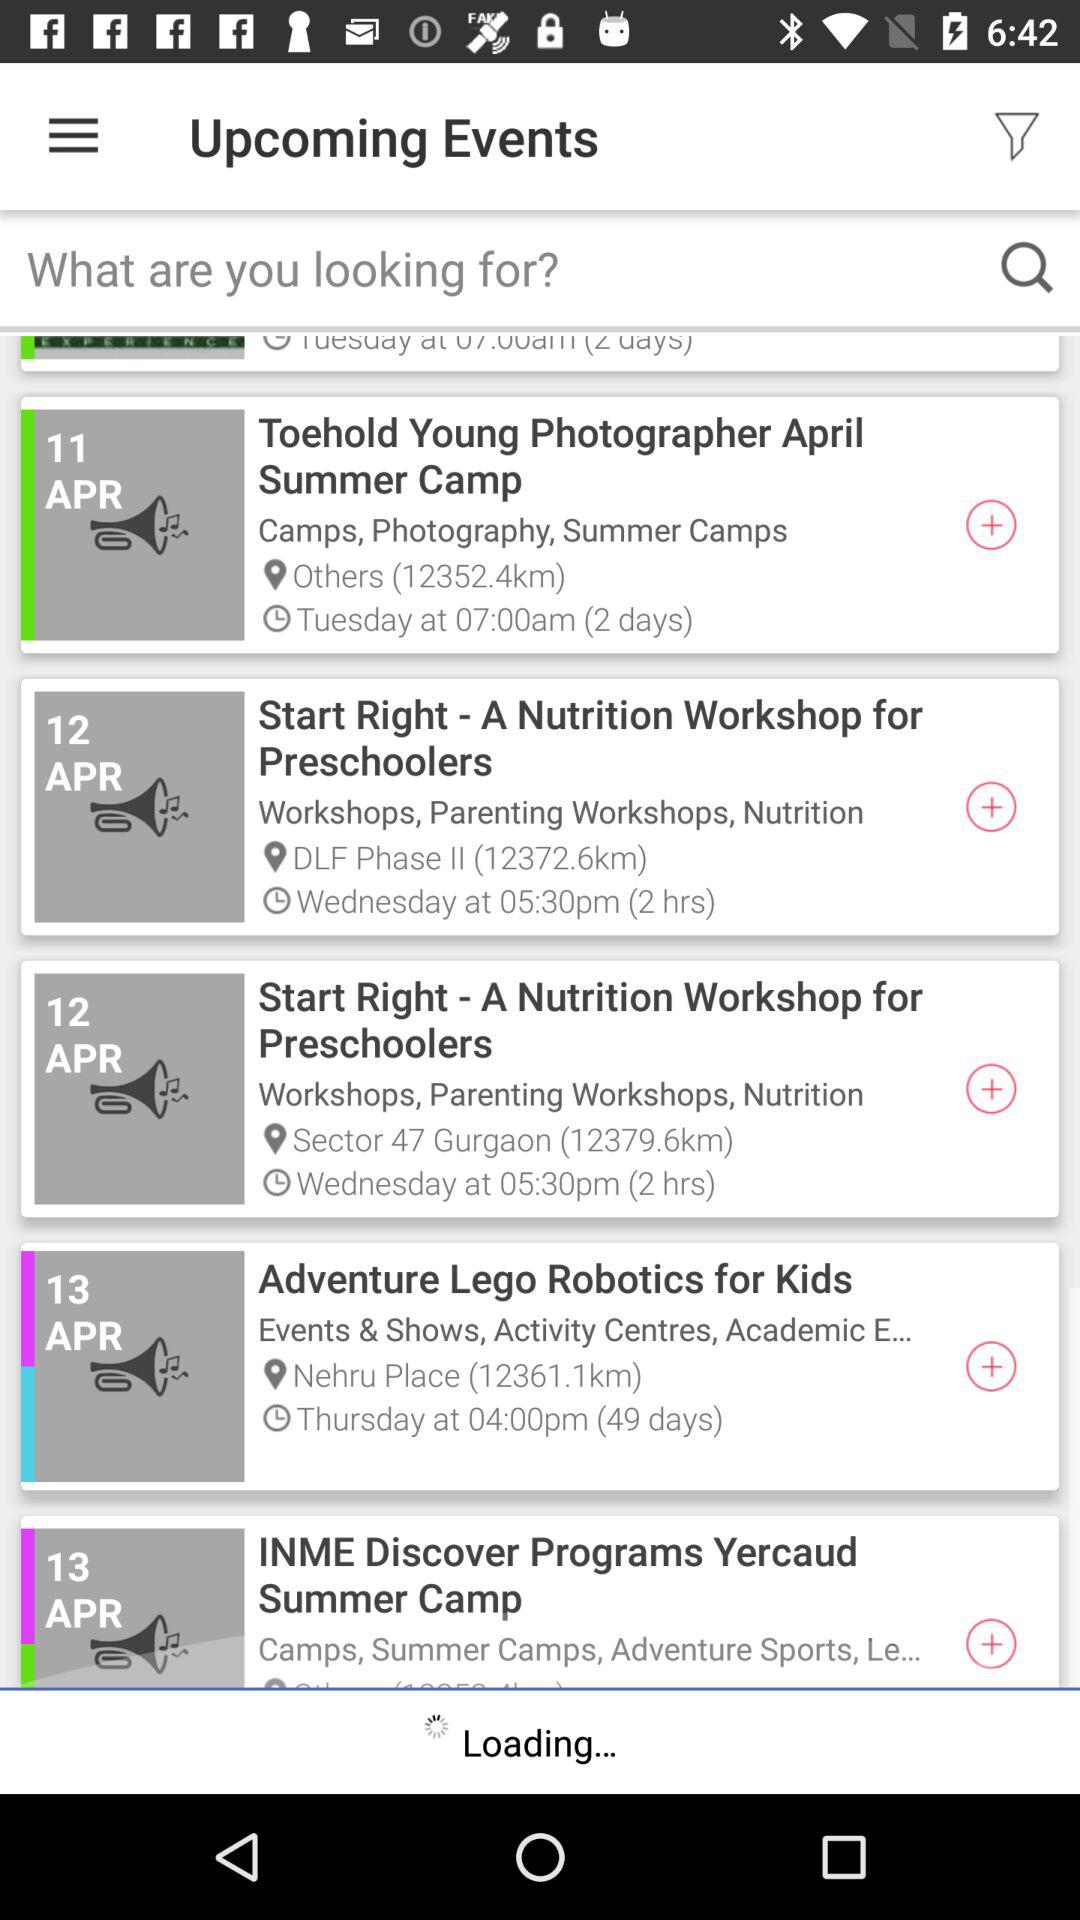What is the time period of "Toehold Young Photographer April Summer Camp"? The time period of "Toehold Young Photographer April Summer Camp" is 2 days. 